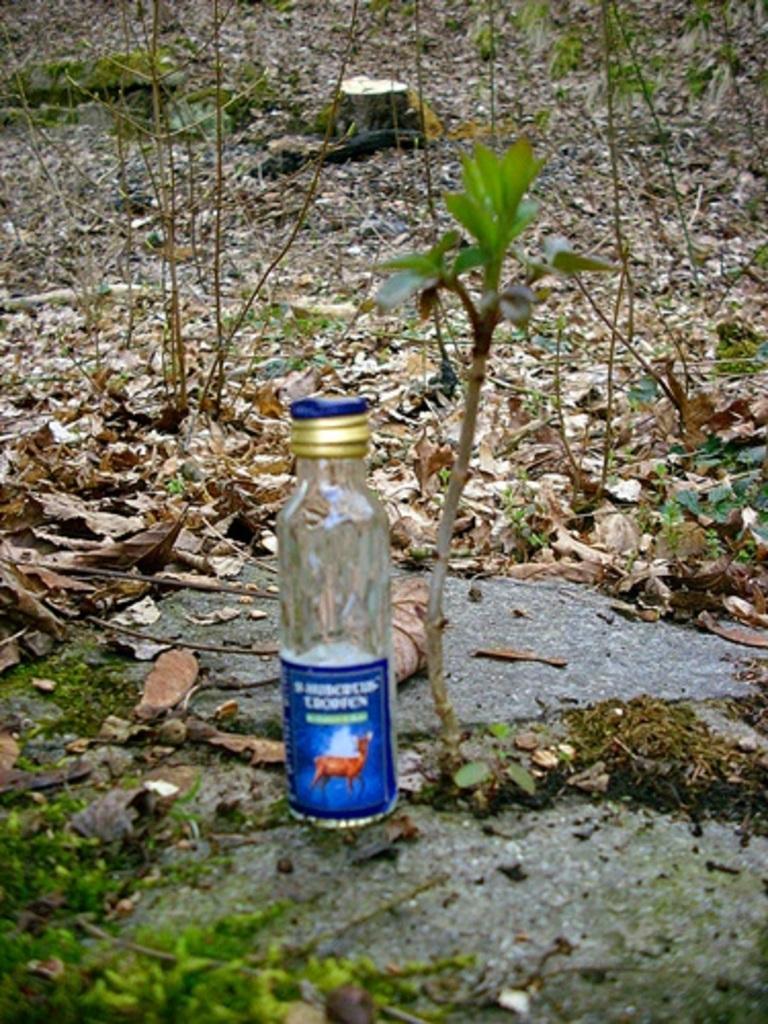Describe this image in one or two sentences. In this picture we can see bottle on rockin in the background we can see trees, leaves. 